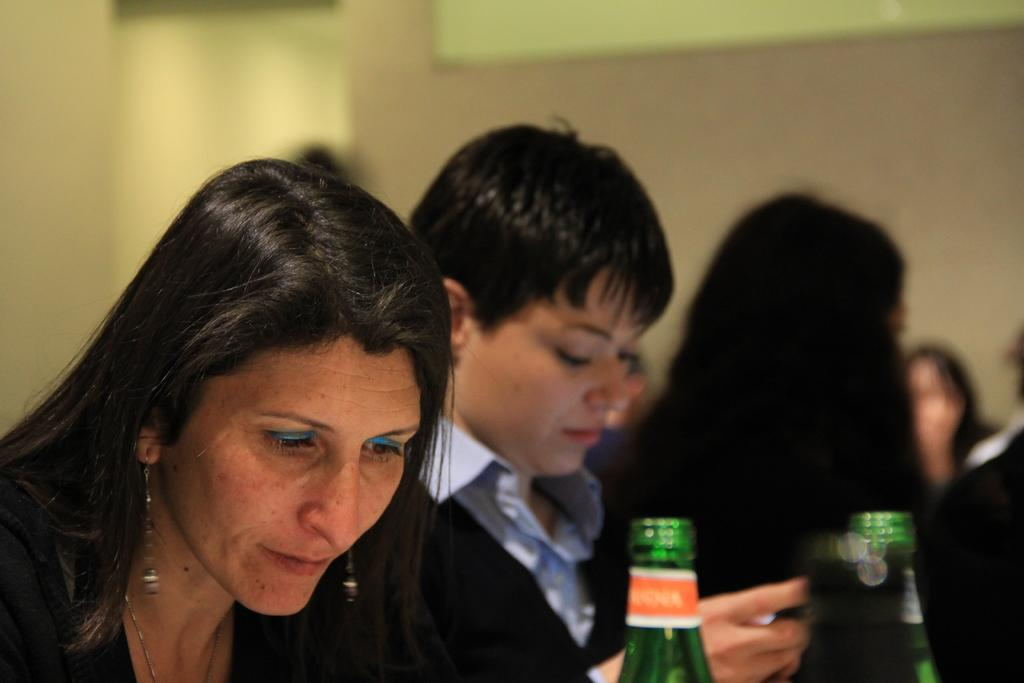What can be seen in the image? There is a group of people in the image. Can you describe the woman in the image? The woman is wearing a black suit and a blue shirt. What is the woman holding in the image? The woman is holding a phone. What else is visible in front of the woman? There are bottles in front of the woman. What type of ornament is hanging from the woman's neck in the image? There is no ornament visible around the woman's neck in the image. Is there a carpenter working in the background of the image? There is no carpenter or any indication of carpentry work in the image. 